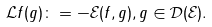Convert formula to latex. <formula><loc_0><loc_0><loc_500><loc_500>\mathcal { L } f ( g ) \colon = - \mathcal { E } ( f , g ) , g \in \mathcal { D } ( \mathcal { E } ) .</formula> 